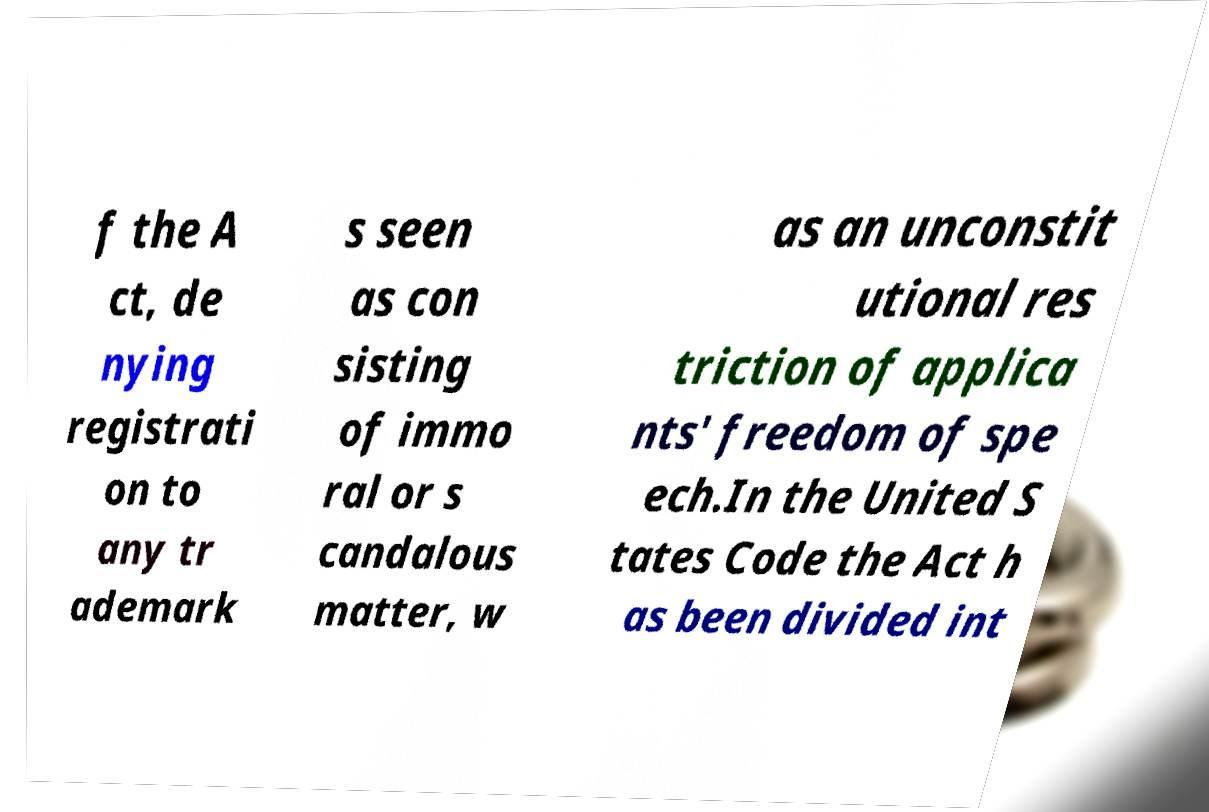For documentation purposes, I need the text within this image transcribed. Could you provide that? f the A ct, de nying registrati on to any tr ademark s seen as con sisting of immo ral or s candalous matter, w as an unconstit utional res triction of applica nts' freedom of spe ech.In the United S tates Code the Act h as been divided int 